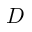<formula> <loc_0><loc_0><loc_500><loc_500>D</formula> 